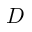<formula> <loc_0><loc_0><loc_500><loc_500>D</formula> 